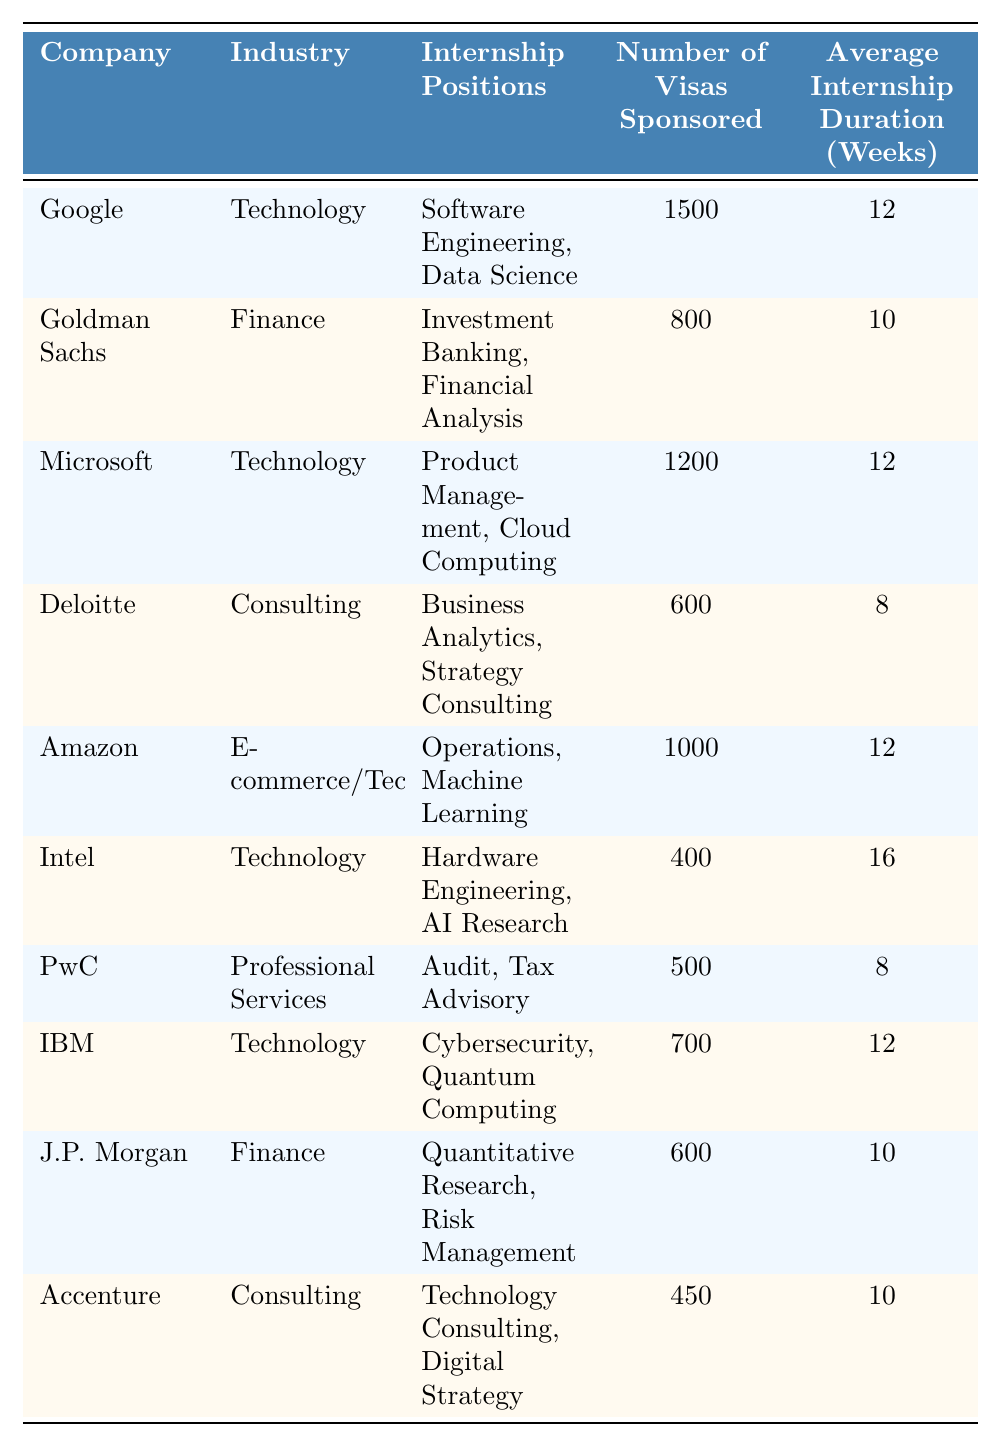What company sponsors the most visas for international students? By examining the "Number of Visas Sponsored" column, I see that Google sponsors 1500 visas, which is the highest among all companies listed.
Answer: Google Which industry has the least number of internship positions available? Looking at the "Internship Positions" column, Intel has 400 internship positions, which is the lowest compared to the others.
Answer: Technology How many weeks is the average internship duration for Deloitte? The table lists that Deloitte has an average internship duration of 8 weeks.
Answer: 8 weeks What is the total number of visas sponsored by Amazon and Goldman Sachs combined? Adding the number of visas sponsored by Amazon (1000) and Goldman Sachs (800), we get 1000 + 800 = 1800.
Answer: 1800 Does PwC offer more internship positions than Accenture? PwC has 500 internship positions while Accenture has 450. Since 500 is greater than 450, the answer is yes.
Answer: Yes What is the average duration of internships across the companies in the technology industry? The average duration is calculated by taking the sum of internship durations for Technology companies: (12 + 12 + 16 + 12) = 52 weeks, and then dividing by the number of technology companies (4). Thus, the average is 52/4 = 13 weeks.
Answer: 13 weeks Which company has the highest average internship duration, and how many weeks does it offer? Intel has the highest average internship duration at 16 weeks, as seen in the "Average Internship Duration (Weeks)" column.
Answer: Intel, 16 weeks Is the average number of internship positions greater than 600? The total number of internship positions across all companies is 1500 + 800 + 1200 + 600 + 1000 + 400 + 500 + 700 + 600 + 450 =  5450. There are 10 companies, so the average is 5450/10 = 545, which is less than 600.
Answer: No Which finance company offers the most internship positions? By looking at the "Internship Positions" for finance companies, Goldman Sachs has 800 positions while J.P. Morgan has 600. Therefore, Goldman Sachs offers the most.
Answer: Goldman Sachs If an international student took an internship at IBM, what would be the total duration for three consecutive internships? The average duration for an IBM internship is 12 weeks, so for three internships, it would be 12 weeks x 3 = 36 weeks total.
Answer: 36 weeks 